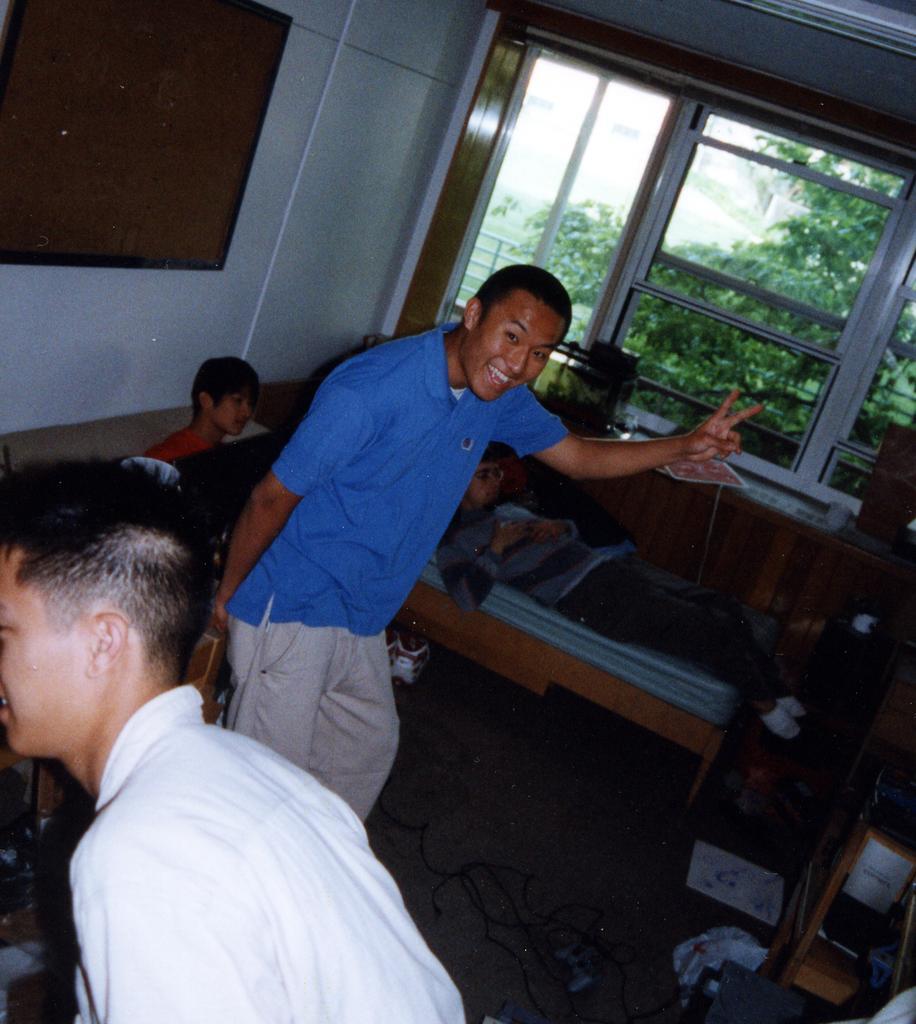Please provide a concise description of this image. These two persons standing. This person laying on bed. This person sitting on the sofa. On the background we can see wall,glass window. From this glass window we can see tree. This is floor. 